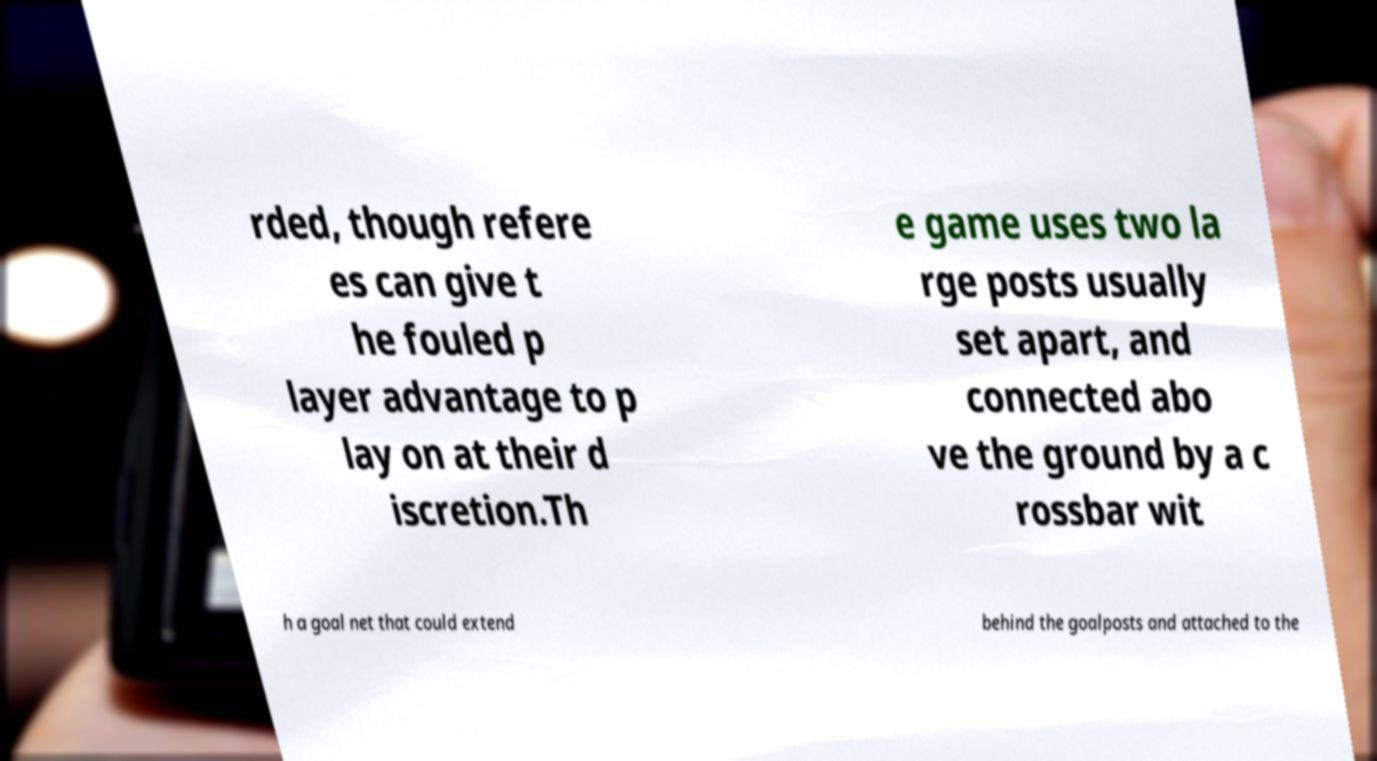Please read and relay the text visible in this image. What does it say? rded, though refere es can give t he fouled p layer advantage to p lay on at their d iscretion.Th e game uses two la rge posts usually set apart, and connected abo ve the ground by a c rossbar wit h a goal net that could extend behind the goalposts and attached to the 